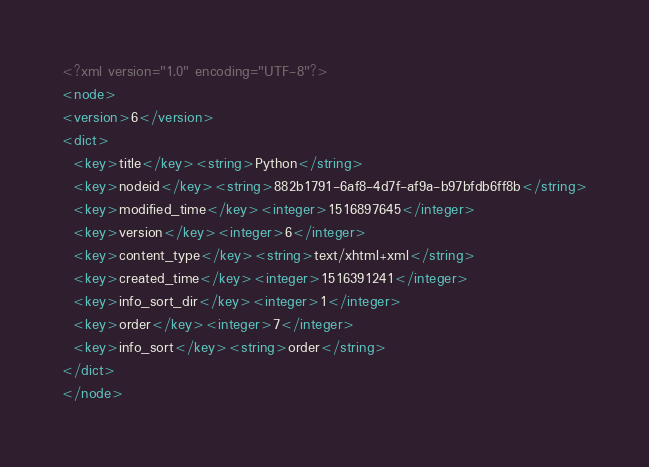Convert code to text. <code><loc_0><loc_0><loc_500><loc_500><_XML_><?xml version="1.0" encoding="UTF-8"?>
<node>
<version>6</version>
<dict>
  <key>title</key><string>Python</string>
  <key>nodeid</key><string>882b1791-6af8-4d7f-af9a-b97bfdb6ff8b</string>
  <key>modified_time</key><integer>1516897645</integer>
  <key>version</key><integer>6</integer>
  <key>content_type</key><string>text/xhtml+xml</string>
  <key>created_time</key><integer>1516391241</integer>
  <key>info_sort_dir</key><integer>1</integer>
  <key>order</key><integer>7</integer>
  <key>info_sort</key><string>order</string>
</dict>
</node>
</code> 